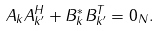Convert formula to latex. <formula><loc_0><loc_0><loc_500><loc_500>A _ { k } A _ { k ^ { \prime } } ^ { H } + B _ { k } ^ { * } B _ { k ^ { \prime } } ^ { T } = 0 _ { N } .</formula> 